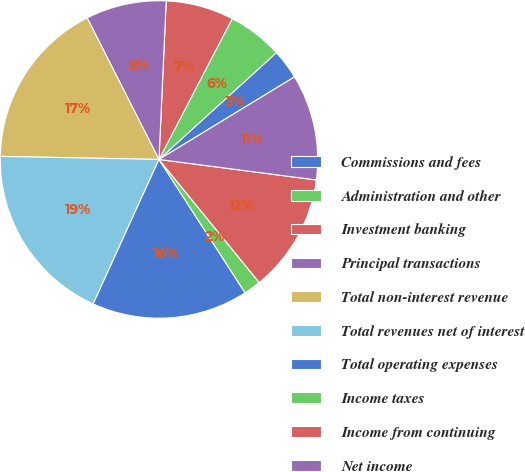Convert chart to OTSL. <chart><loc_0><loc_0><loc_500><loc_500><pie_chart><fcel>Commissions and fees<fcel>Administration and other<fcel>Investment banking<fcel>Principal transactions<fcel>Total non-interest revenue<fcel>Total revenues net of interest<fcel>Total operating expenses<fcel>Income taxes<fcel>Income from continuing<fcel>Net income<nl><fcel>3.04%<fcel>5.62%<fcel>6.91%<fcel>8.2%<fcel>17.22%<fcel>18.51%<fcel>15.93%<fcel>1.75%<fcel>12.06%<fcel>10.77%<nl></chart> 